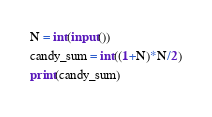Convert code to text. <code><loc_0><loc_0><loc_500><loc_500><_Python_>N = int(input())
candy_sum = int((1+N)*N/2)
print(candy_sum)</code> 